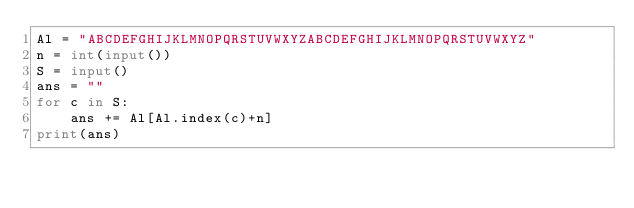<code> <loc_0><loc_0><loc_500><loc_500><_Python_>Al = "ABCDEFGHIJKLMNOPQRSTUVWXYZABCDEFGHIJKLMNOPQRSTUVWXYZ"
n = int(input())
S = input()
ans = ""
for c in S:
    ans += Al[Al.index(c)+n]
print(ans)</code> 